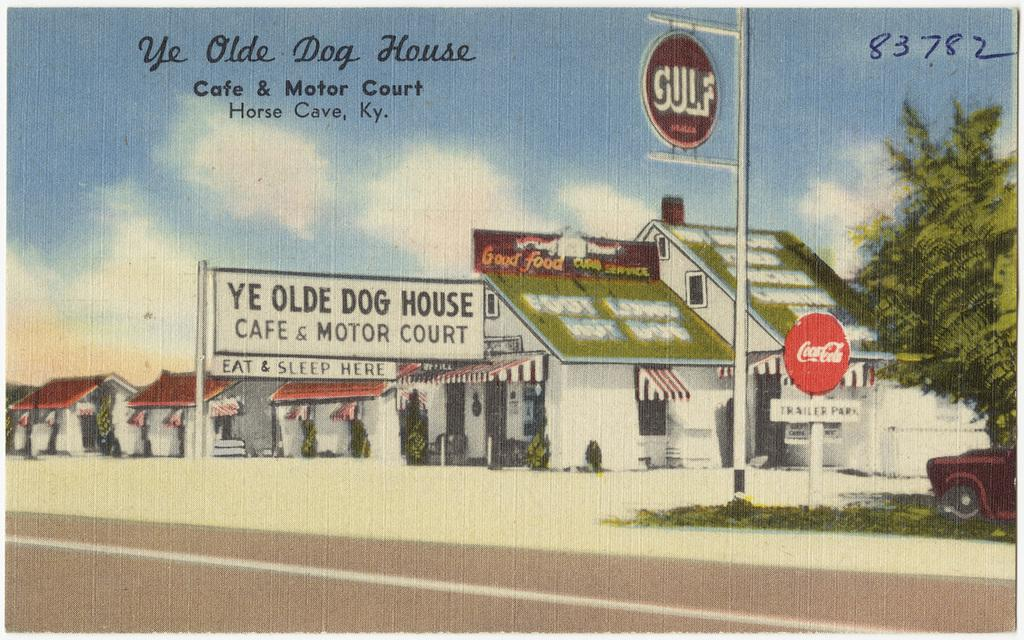<image>
Provide a brief description of the given image. A drawing of an old cafe and motor court called ye olde dog house. 